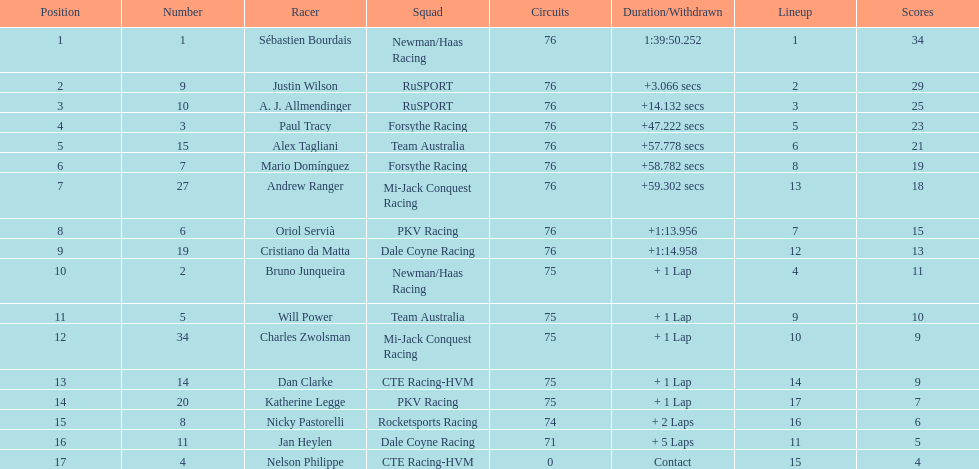Which canadian driver finished first: alex tagliani or paul tracy? Paul Tracy. 